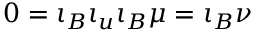Convert formula to latex. <formula><loc_0><loc_0><loc_500><loc_500>0 = \iota _ { B } \iota _ { u } \iota _ { B } \mu = \iota _ { B } \nu</formula> 